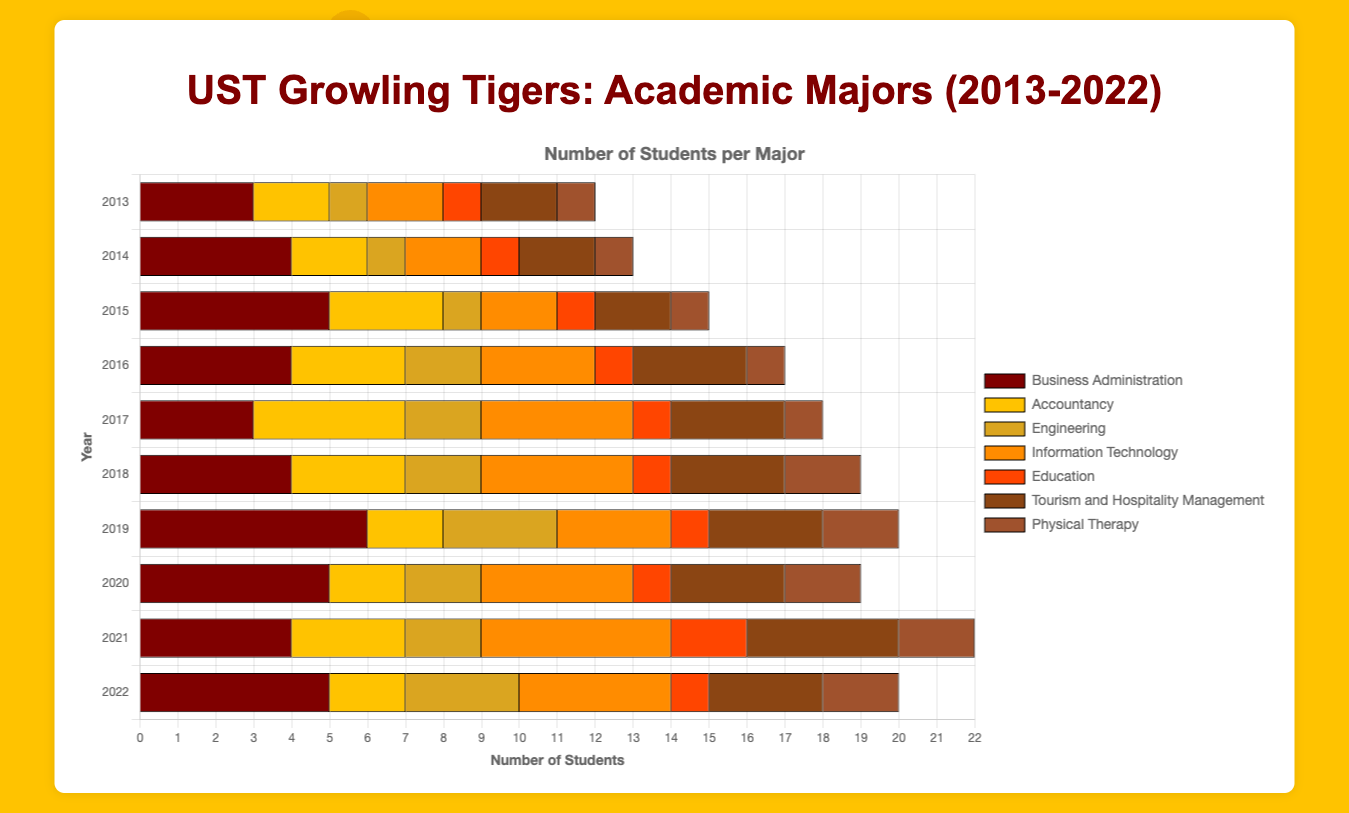What's the total number of UST Growling Tigers players majoring in Business Administration over the entire decade? Sum the values for Business Administration from 2013 to 2022: (3 + 4 + 5 + 4 + 3 + 4 + 6 + 5 + 4 + 5) = 43
Answer: 43 Which major had the most students in 2019? Look at the data for 2019 and identify which major had the highest number: Business Administration (6), Accountancy (2), Engineering (3), Information Technology (3), Education (1), Tourism and Hospitality Management (3), Physical Therapy (2). Business Administration had the highest number with 6 students.
Answer: Business Administration In which year did Engineering and Information Technology have the same number of students? Compare the data for Engineering and Information Technology across all years. They both have the same number of students in 2020, with 2 students each.
Answer: 2020 What is the average number of students in Accountancy from 2018 to 2022? Sum the values for Accountancy from 2018 to 2022 and divide by the number of years: (3 + 2 + 2 + 3 + 2) = 12, then 12 / 5 = 2.4
Answer: 2.4 How many more students majored in Physical Therapy in 2022 compared to 2013? Subtract the number of Physical Therapy students in 2013 from those in 2022: 2 (2022) - 1 (2013) = 1
Answer: 1 Which major had the least consistency in student numbers across the decade? Look at the fluctuations in student numbers for each major from 2013 to 2022. Business Administration (max - min = 6 - 3 = 3), Accountancy (min = 2 and max = 4, range 2), Engineering (range 2), Information Technology (range 3), Education (range 1), Tourism and Hospitality Management (range 2), Physical Therapy (range 1). Business Administration had the least consistency with a range of 3.
Answer: Business Administration Which major had an increase in students every year between 2013 and 2015? Check the data for each major to see if the number of students increased from 2013 to 2015: Business Administration (3, 4, 5), Accountancy (2, 2, 3), Engineering (1, 1, 1), Information Technology (2, 2, 2), Education (1, 1, 1), Tourism and Hospitality Management (2, 2, 2), Physical Therapy (1, 1, 1). Business Administration had an increase every year between 2013 and 2015.
Answer: Business Administration How many majors saw a peak number of students in 2021? Identify the peak year for each major: Business Administration (2019), Accountancy (2017), Engineering (2022), Information Technology (2021), Education (2021), Tourism and Hospitality Management (2021), Physical Therapy (2021). Four majors peaked in 2021.
Answer: 4 What was the most common major in 2016? Look at the number of students in each major for 2016: Business Administration (4), Accountancy (3), Engineering (2), Information Technology (3), Education (1), Tourism and Hospitality Management (3), Physical Therapy (1). Business Administration had the highest count.
Answer: Business Administration 